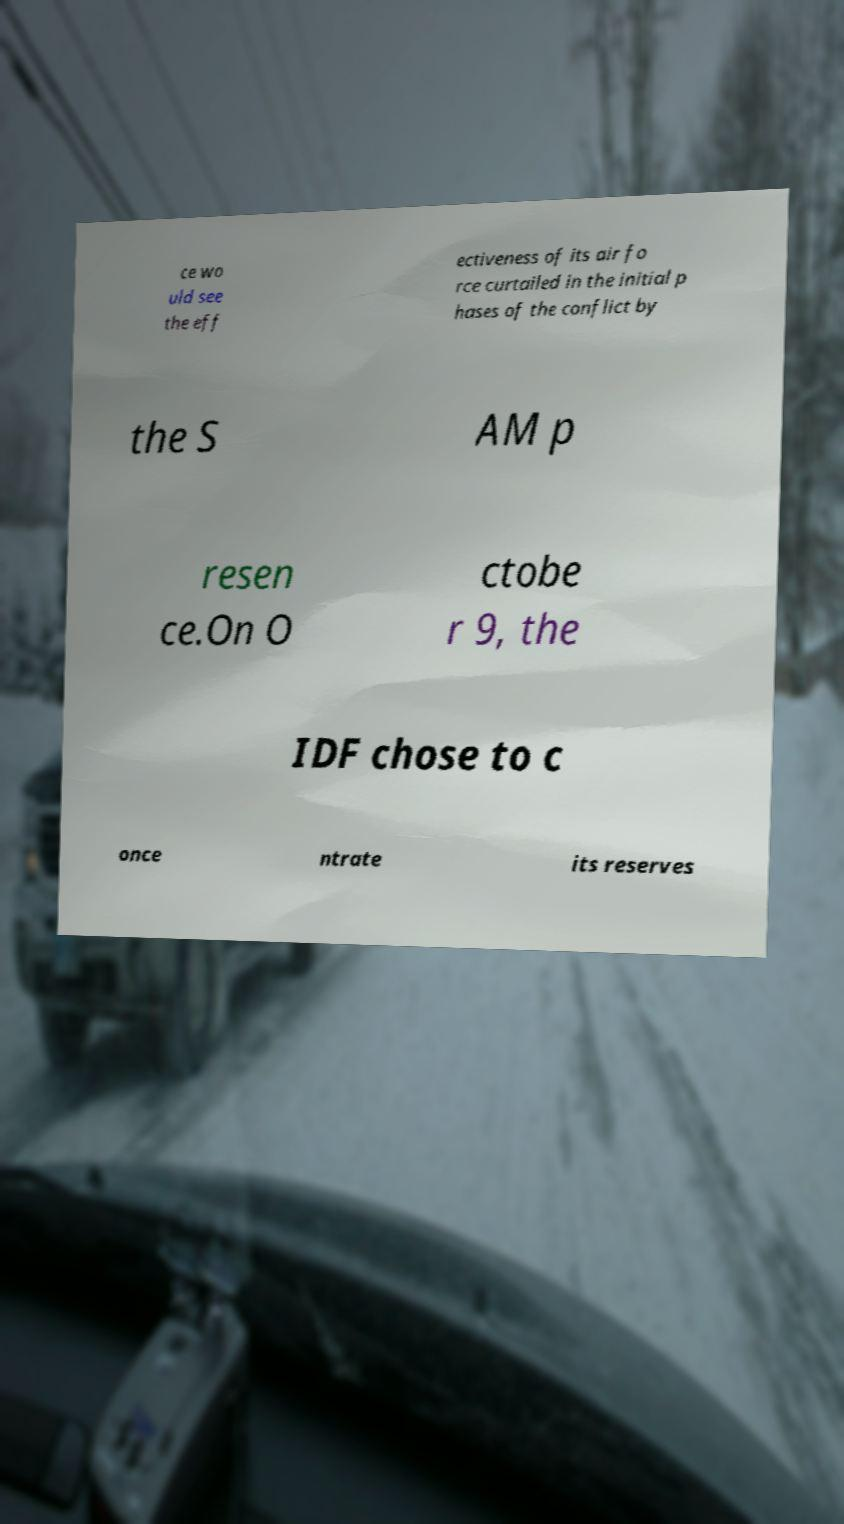Can you read and provide the text displayed in the image?This photo seems to have some interesting text. Can you extract and type it out for me? ce wo uld see the eff ectiveness of its air fo rce curtailed in the initial p hases of the conflict by the S AM p resen ce.On O ctobe r 9, the IDF chose to c once ntrate its reserves 